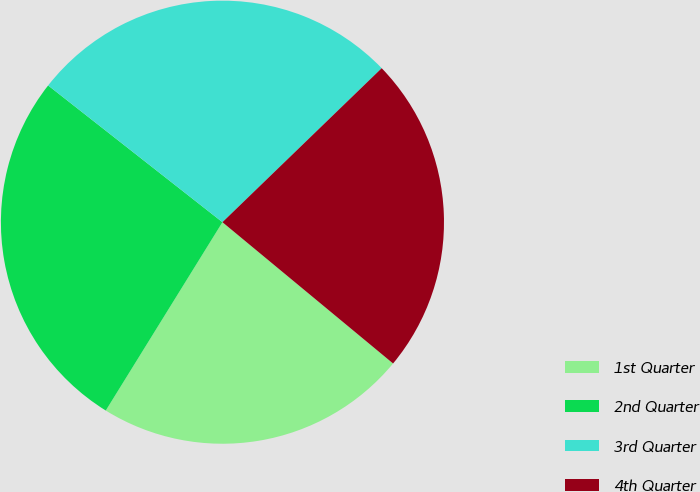Convert chart to OTSL. <chart><loc_0><loc_0><loc_500><loc_500><pie_chart><fcel>1st Quarter<fcel>2nd Quarter<fcel>3rd Quarter<fcel>4th Quarter<nl><fcel>22.82%<fcel>26.76%<fcel>27.18%<fcel>23.24%<nl></chart> 